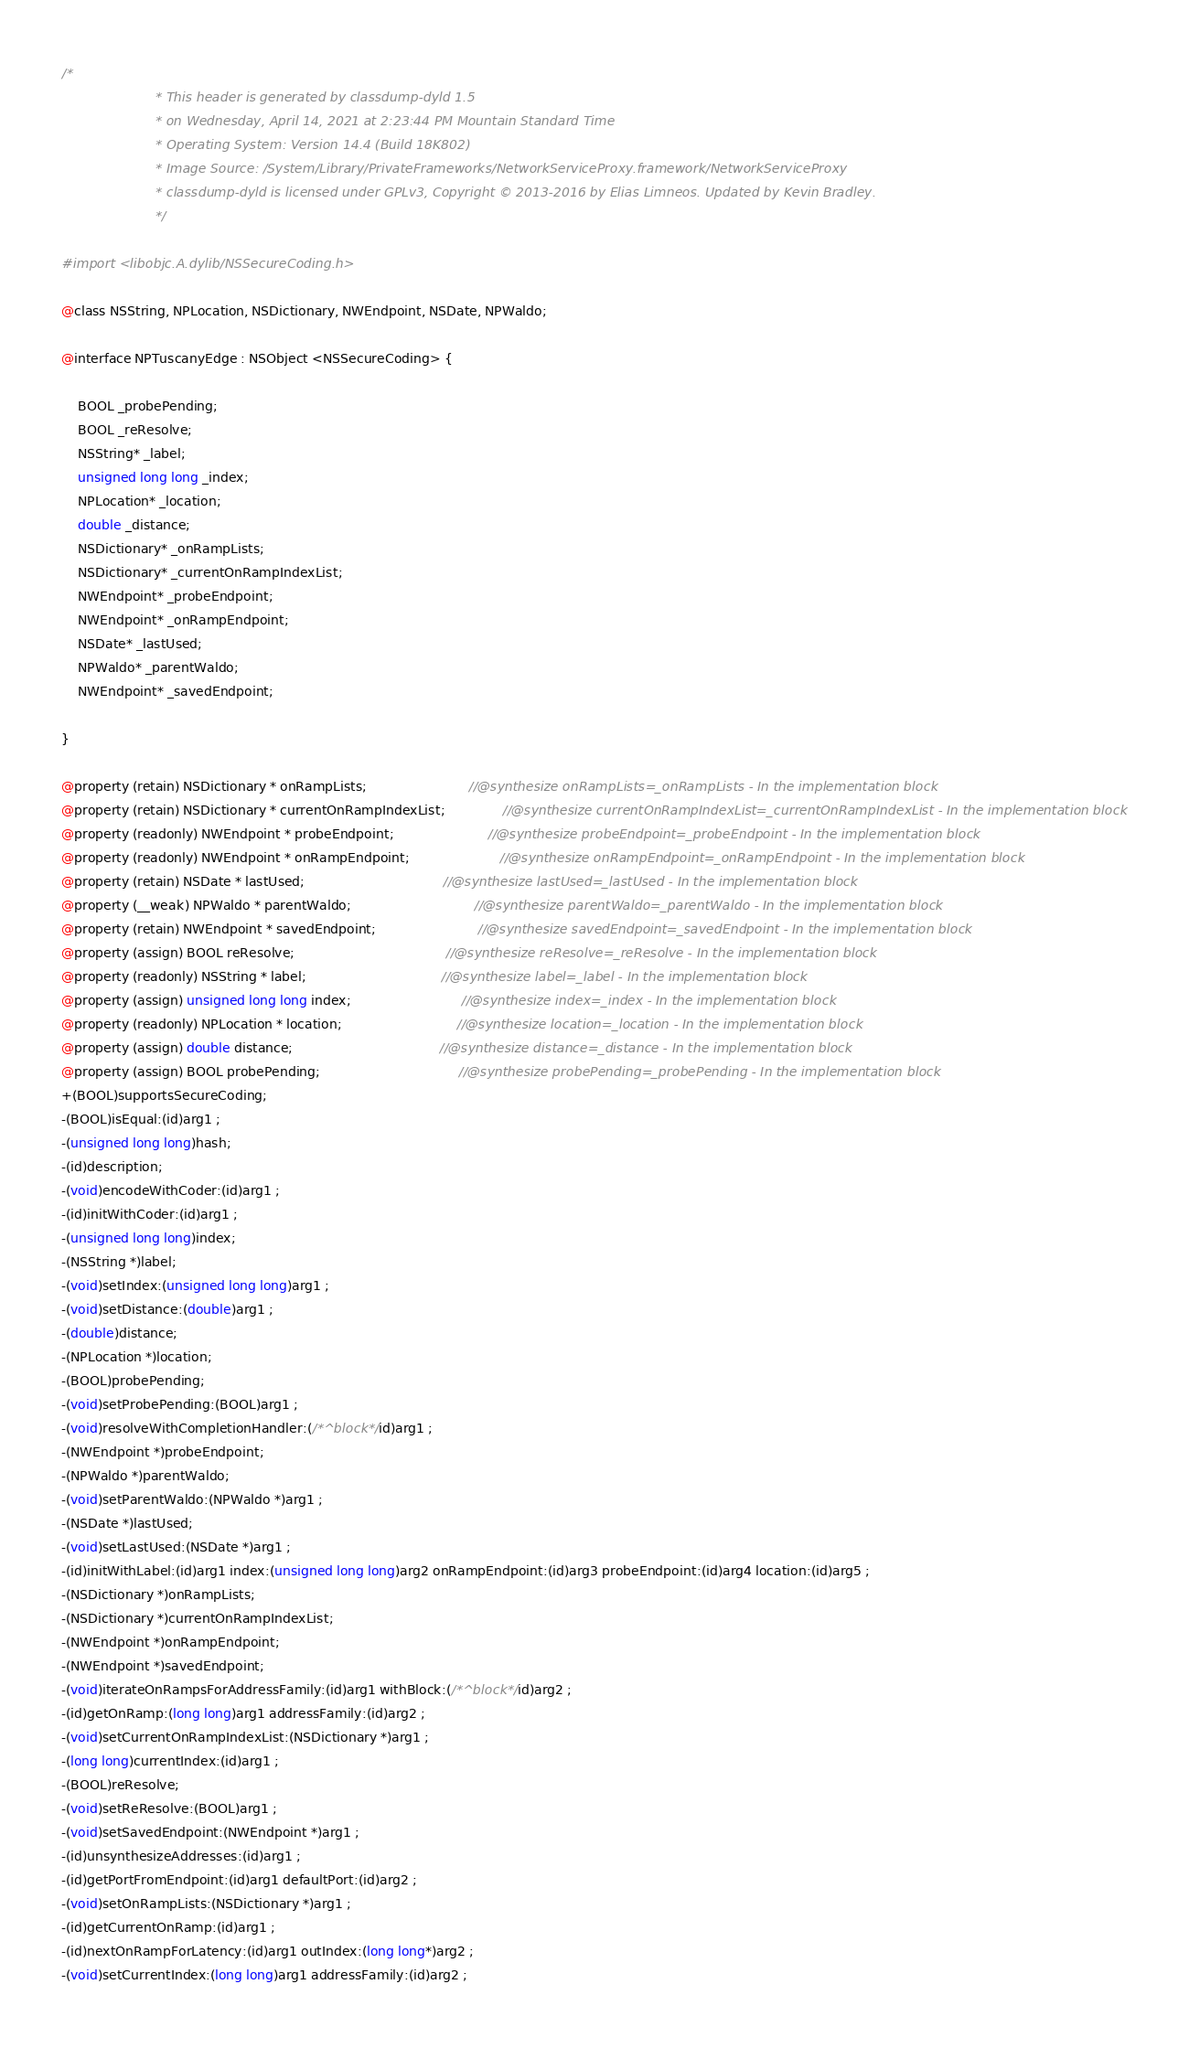Convert code to text. <code><loc_0><loc_0><loc_500><loc_500><_C_>/*
                       * This header is generated by classdump-dyld 1.5
                       * on Wednesday, April 14, 2021 at 2:23:44 PM Mountain Standard Time
                       * Operating System: Version 14.4 (Build 18K802)
                       * Image Source: /System/Library/PrivateFrameworks/NetworkServiceProxy.framework/NetworkServiceProxy
                       * classdump-dyld is licensed under GPLv3, Copyright © 2013-2016 by Elias Limneos. Updated by Kevin Bradley.
                       */

#import <libobjc.A.dylib/NSSecureCoding.h>

@class NSString, NPLocation, NSDictionary, NWEndpoint, NSDate, NPWaldo;

@interface NPTuscanyEdge : NSObject <NSSecureCoding> {

	BOOL _probePending;
	BOOL _reResolve;
	NSString* _label;
	unsigned long long _index;
	NPLocation* _location;
	double _distance;
	NSDictionary* _onRampLists;
	NSDictionary* _currentOnRampIndexList;
	NWEndpoint* _probeEndpoint;
	NWEndpoint* _onRampEndpoint;
	NSDate* _lastUsed;
	NPWaldo* _parentWaldo;
	NWEndpoint* _savedEndpoint;

}

@property (retain) NSDictionary * onRampLists;                         //@synthesize onRampLists=_onRampLists - In the implementation block
@property (retain) NSDictionary * currentOnRampIndexList;              //@synthesize currentOnRampIndexList=_currentOnRampIndexList - In the implementation block
@property (readonly) NWEndpoint * probeEndpoint;                       //@synthesize probeEndpoint=_probeEndpoint - In the implementation block
@property (readonly) NWEndpoint * onRampEndpoint;                      //@synthesize onRampEndpoint=_onRampEndpoint - In the implementation block
@property (retain) NSDate * lastUsed;                                  //@synthesize lastUsed=_lastUsed - In the implementation block
@property (__weak) NPWaldo * parentWaldo;                              //@synthesize parentWaldo=_parentWaldo - In the implementation block
@property (retain) NWEndpoint * savedEndpoint;                         //@synthesize savedEndpoint=_savedEndpoint - In the implementation block
@property (assign) BOOL reResolve;                                     //@synthesize reResolve=_reResolve - In the implementation block
@property (readonly) NSString * label;                                 //@synthesize label=_label - In the implementation block
@property (assign) unsigned long long index;                           //@synthesize index=_index - In the implementation block
@property (readonly) NPLocation * location;                            //@synthesize location=_location - In the implementation block
@property (assign) double distance;                                    //@synthesize distance=_distance - In the implementation block
@property (assign) BOOL probePending;                                  //@synthesize probePending=_probePending - In the implementation block
+(BOOL)supportsSecureCoding;
-(BOOL)isEqual:(id)arg1 ;
-(unsigned long long)hash;
-(id)description;
-(void)encodeWithCoder:(id)arg1 ;
-(id)initWithCoder:(id)arg1 ;
-(unsigned long long)index;
-(NSString *)label;
-(void)setIndex:(unsigned long long)arg1 ;
-(void)setDistance:(double)arg1 ;
-(double)distance;
-(NPLocation *)location;
-(BOOL)probePending;
-(void)setProbePending:(BOOL)arg1 ;
-(void)resolveWithCompletionHandler:(/*^block*/id)arg1 ;
-(NWEndpoint *)probeEndpoint;
-(NPWaldo *)parentWaldo;
-(void)setParentWaldo:(NPWaldo *)arg1 ;
-(NSDate *)lastUsed;
-(void)setLastUsed:(NSDate *)arg1 ;
-(id)initWithLabel:(id)arg1 index:(unsigned long long)arg2 onRampEndpoint:(id)arg3 probeEndpoint:(id)arg4 location:(id)arg5 ;
-(NSDictionary *)onRampLists;
-(NSDictionary *)currentOnRampIndexList;
-(NWEndpoint *)onRampEndpoint;
-(NWEndpoint *)savedEndpoint;
-(void)iterateOnRampsForAddressFamily:(id)arg1 withBlock:(/*^block*/id)arg2 ;
-(id)getOnRamp:(long long)arg1 addressFamily:(id)arg2 ;
-(void)setCurrentOnRampIndexList:(NSDictionary *)arg1 ;
-(long long)currentIndex:(id)arg1 ;
-(BOOL)reResolve;
-(void)setReResolve:(BOOL)arg1 ;
-(void)setSavedEndpoint:(NWEndpoint *)arg1 ;
-(id)unsynthesizeAddresses:(id)arg1 ;
-(id)getPortFromEndpoint:(id)arg1 defaultPort:(id)arg2 ;
-(void)setOnRampLists:(NSDictionary *)arg1 ;
-(id)getCurrentOnRamp:(id)arg1 ;
-(id)nextOnRampForLatency:(id)arg1 outIndex:(long long*)arg2 ;
-(void)setCurrentIndex:(long long)arg1 addressFamily:(id)arg2 ;</code> 